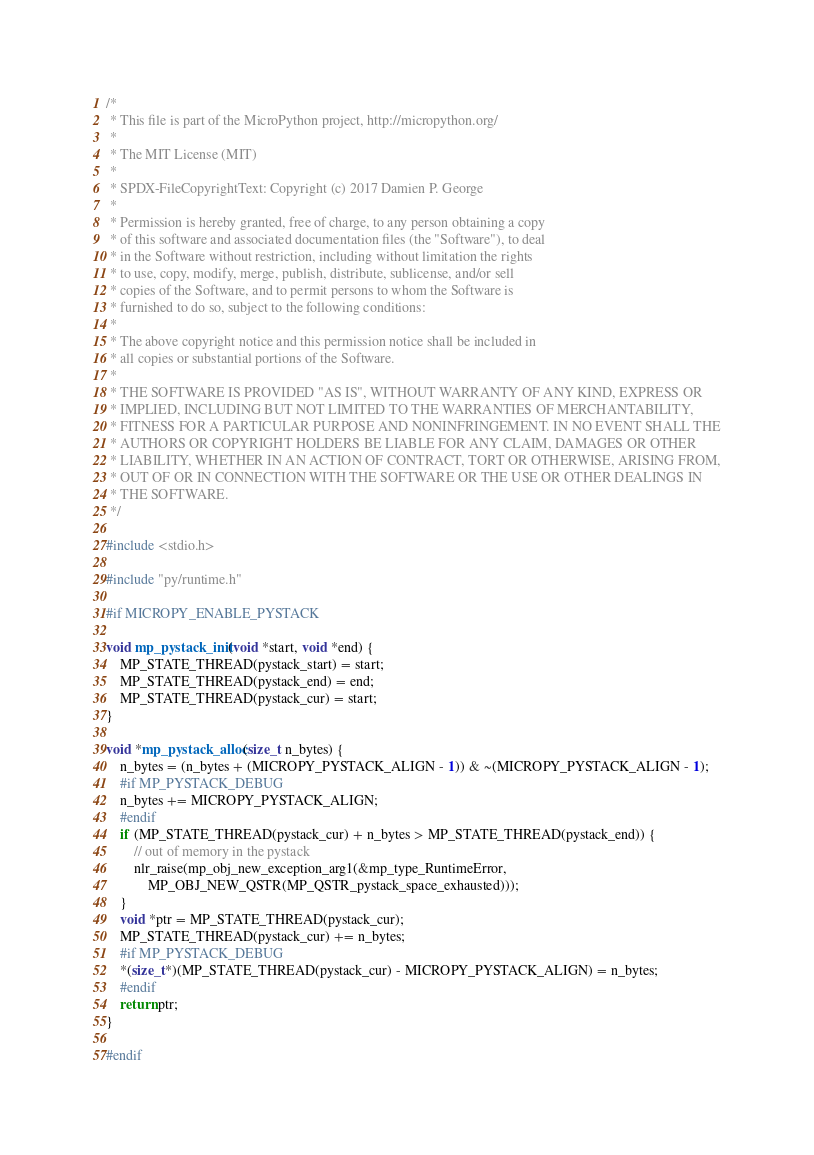<code> <loc_0><loc_0><loc_500><loc_500><_C_>/*
 * This file is part of the MicroPython project, http://micropython.org/
 *
 * The MIT License (MIT)
 *
 * SPDX-FileCopyrightText: Copyright (c) 2017 Damien P. George
 *
 * Permission is hereby granted, free of charge, to any person obtaining a copy
 * of this software and associated documentation files (the "Software"), to deal
 * in the Software without restriction, including without limitation the rights
 * to use, copy, modify, merge, publish, distribute, sublicense, and/or sell
 * copies of the Software, and to permit persons to whom the Software is
 * furnished to do so, subject to the following conditions:
 *
 * The above copyright notice and this permission notice shall be included in
 * all copies or substantial portions of the Software.
 *
 * THE SOFTWARE IS PROVIDED "AS IS", WITHOUT WARRANTY OF ANY KIND, EXPRESS OR
 * IMPLIED, INCLUDING BUT NOT LIMITED TO THE WARRANTIES OF MERCHANTABILITY,
 * FITNESS FOR A PARTICULAR PURPOSE AND NONINFRINGEMENT. IN NO EVENT SHALL THE
 * AUTHORS OR COPYRIGHT HOLDERS BE LIABLE FOR ANY CLAIM, DAMAGES OR OTHER
 * LIABILITY, WHETHER IN AN ACTION OF CONTRACT, TORT OR OTHERWISE, ARISING FROM,
 * OUT OF OR IN CONNECTION WITH THE SOFTWARE OR THE USE OR OTHER DEALINGS IN
 * THE SOFTWARE.
 */

#include <stdio.h>

#include "py/runtime.h"

#if MICROPY_ENABLE_PYSTACK

void mp_pystack_init(void *start, void *end) {
    MP_STATE_THREAD(pystack_start) = start;
    MP_STATE_THREAD(pystack_end) = end;
    MP_STATE_THREAD(pystack_cur) = start;
}

void *mp_pystack_alloc(size_t n_bytes) {
    n_bytes = (n_bytes + (MICROPY_PYSTACK_ALIGN - 1)) & ~(MICROPY_PYSTACK_ALIGN - 1);
    #if MP_PYSTACK_DEBUG
    n_bytes += MICROPY_PYSTACK_ALIGN;
    #endif
    if (MP_STATE_THREAD(pystack_cur) + n_bytes > MP_STATE_THREAD(pystack_end)) {
        // out of memory in the pystack
        nlr_raise(mp_obj_new_exception_arg1(&mp_type_RuntimeError,
            MP_OBJ_NEW_QSTR(MP_QSTR_pystack_space_exhausted)));
    }
    void *ptr = MP_STATE_THREAD(pystack_cur);
    MP_STATE_THREAD(pystack_cur) += n_bytes;
    #if MP_PYSTACK_DEBUG
    *(size_t*)(MP_STATE_THREAD(pystack_cur) - MICROPY_PYSTACK_ALIGN) = n_bytes;
    #endif
    return ptr;
}

#endif
</code> 